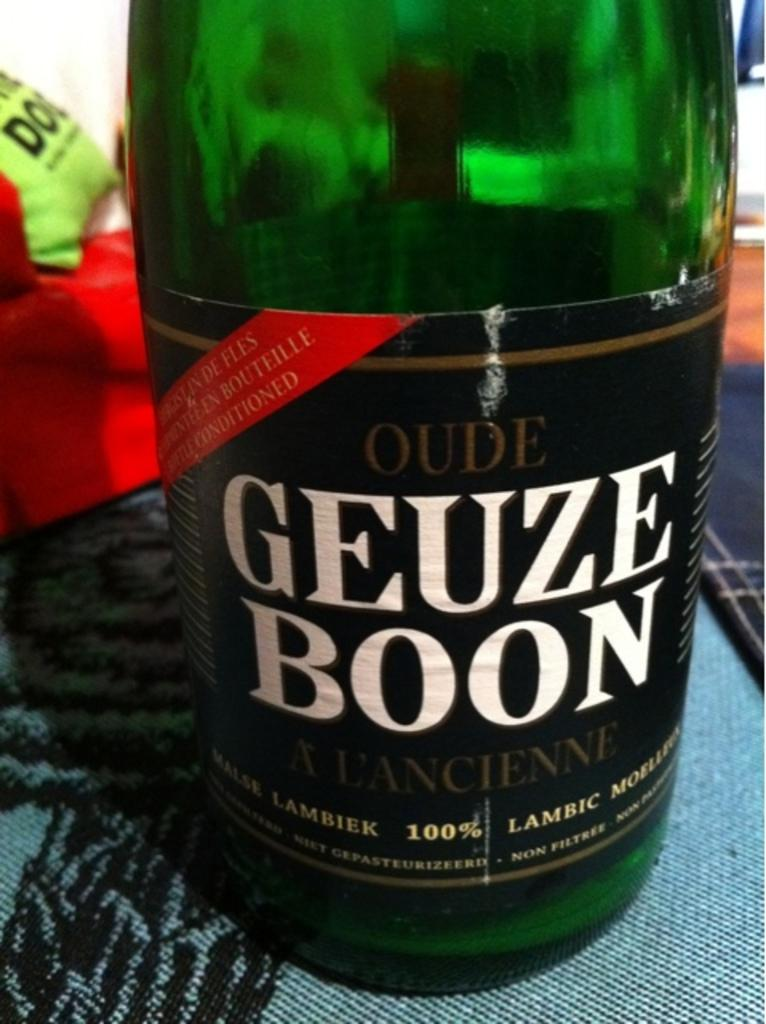What object is partially visible in the image? There is a bottle in the image that is half-visible. Where is the bottle located in the image? The bottle is on the floor in the image. What color is the cloth visible in the image? The cloth visible in the image is red. Can you describe the setting of the image? The image was taken inside a room. How does the wind affect the cakes in the image? There are no cakes present in the image, so the wind's effect on cakes cannot be determined. 